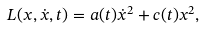<formula> <loc_0><loc_0><loc_500><loc_500>L ( x , \dot { x } , t ) = a ( t ) \dot { x } ^ { 2 } + c ( t ) x ^ { 2 } ,</formula> 